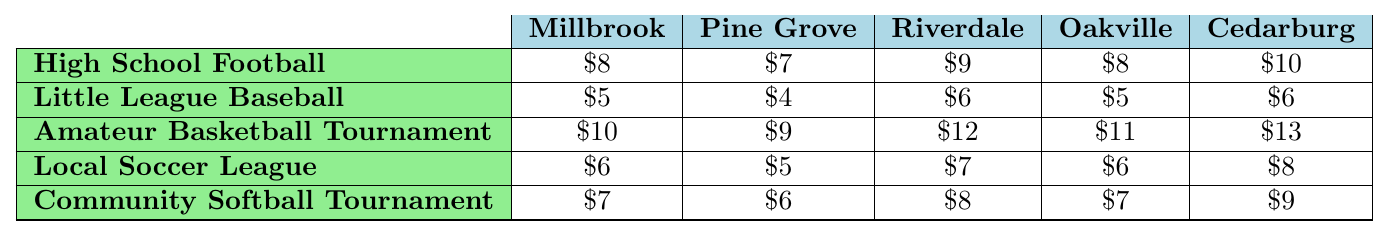What is the ticket price for High School Football in Pine Grove? The table shows the ticket prices for various sports events in different towns. For High School Football in Pine Grove, the ticket price is listed as $7.
Answer: $7 Which town has the highest ticket price for the Amateur Basketball Tournament? The highest ticket price for the Amateur Basketball Tournament can be identified by comparing the values in that row across all towns. Cedarburg has the highest price at $13.
Answer: $13 What is the average ticket price for Little League Baseball across all towns? To find the average, add the ticket prices for Little League Baseball: 5 + 4 + 6 + 5 + 6 = 26. Then divide by the number of towns (5), resulting in an average of 26/5 = 5.2.
Answer: $5.20 True or False: Riverdale has a lower ticket price for Local Soccer League than Millbrook. By comparing the ticket prices for the Local Soccer League, Riverdale is $7 and Millbrook is $6. Since $7 is not lower than $6, the statement is false.
Answer: False In which event does Oakville charge the least amount for tickets compared to other towns? By checking Oakville's ticket prices against other towns, for Little League Baseball, it charges $5, which is the least compared to the other towns (Pine Grove also charges $4 but not lower than Oakville when compared).
Answer: Little League Baseball What is the difference in ticket prices for the Community Softball Tournament between Cedarburg and Pine Grove? To find the difference, subtract Pine Grove's price from Cedarburg's: $9 (Cedarburg) - $6 (Pine Grove) = $3.
Answer: $3 Which event has the highest ticket price in Millbrook and what is that price? From the table, the ticket prices for all events in Millbrook are compared. The highest price is for the Amateur Basketball Tournament, which is $10.
Answer: $10 If you add the ticket prices for Local Soccer League across all towns, what is the total? The total can be calculated as follows: $6 (Millbrook) + $5 (Pine Grove) + $7 (Riverdale) + $6 (Oakville) + $8 (Cedarburg) = $32.
Answer: $32 How many towns charge $8 or more for High School Football tickets? By examining the ticket prices for High School Football: Millbrook ($8), Pine Grove ($7), Riverdale ($9), Oakville ($8), Cedarburg ($10), there are three towns (Riverdale, Oakville, Cedarburg) that charge $8 or more.
Answer: 3 What town has the lowest overall ticket prices for sports events? To find the lowest overall ticket prices, sum each town's prices and compare: Millbrook ($36), Pine Grove ($30), Riverdale ($42), Oakville ($37), Cedarburg ($46). Pine Grove has the lowest total at $30.
Answer: Pine Grove 